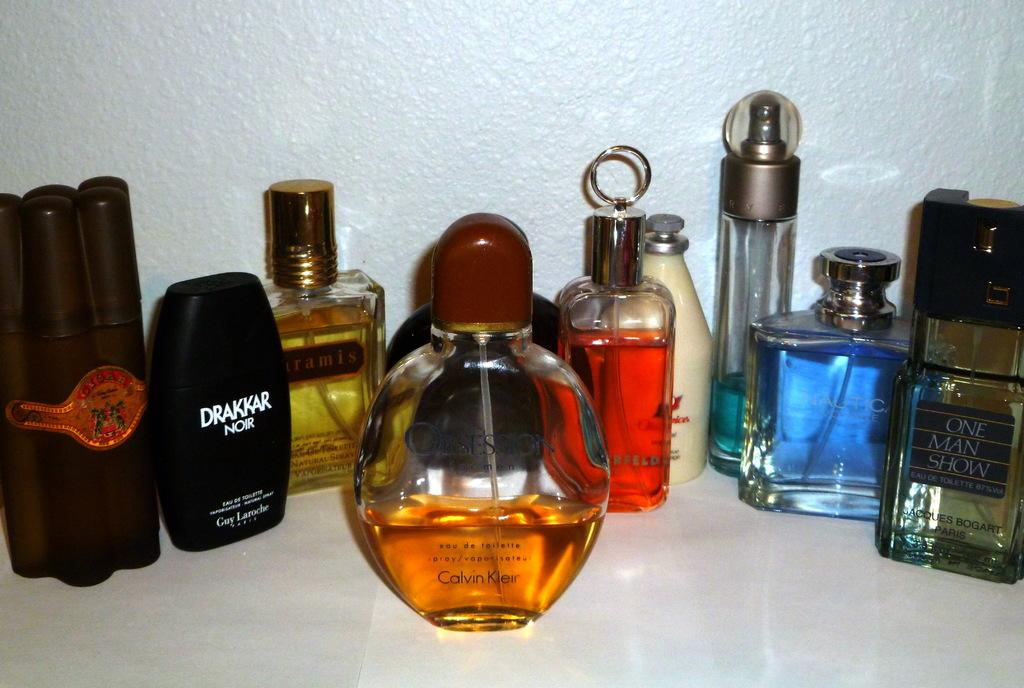Provide a one-sentence caption for the provided image. A group of perfume bottles on a table, one is Drakkar. 